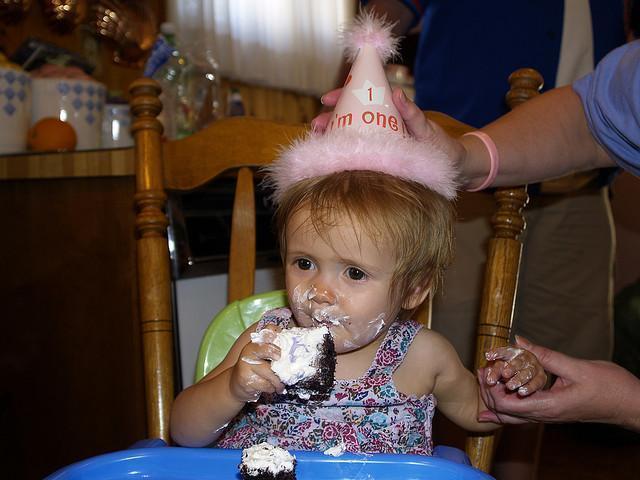How many cakes are in the photo?
Give a very brief answer. 1. How many people are visible?
Give a very brief answer. 3. 